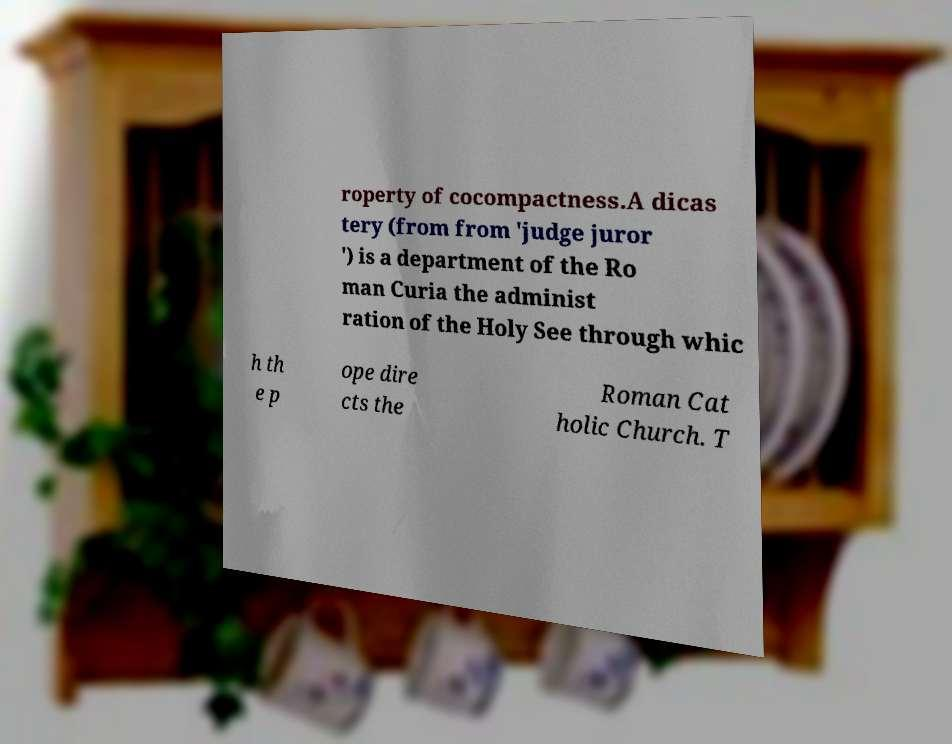Please identify and transcribe the text found in this image. roperty of cocompactness.A dicas tery (from from 'judge juror ') is a department of the Ro man Curia the administ ration of the Holy See through whic h th e p ope dire cts the Roman Cat holic Church. T 